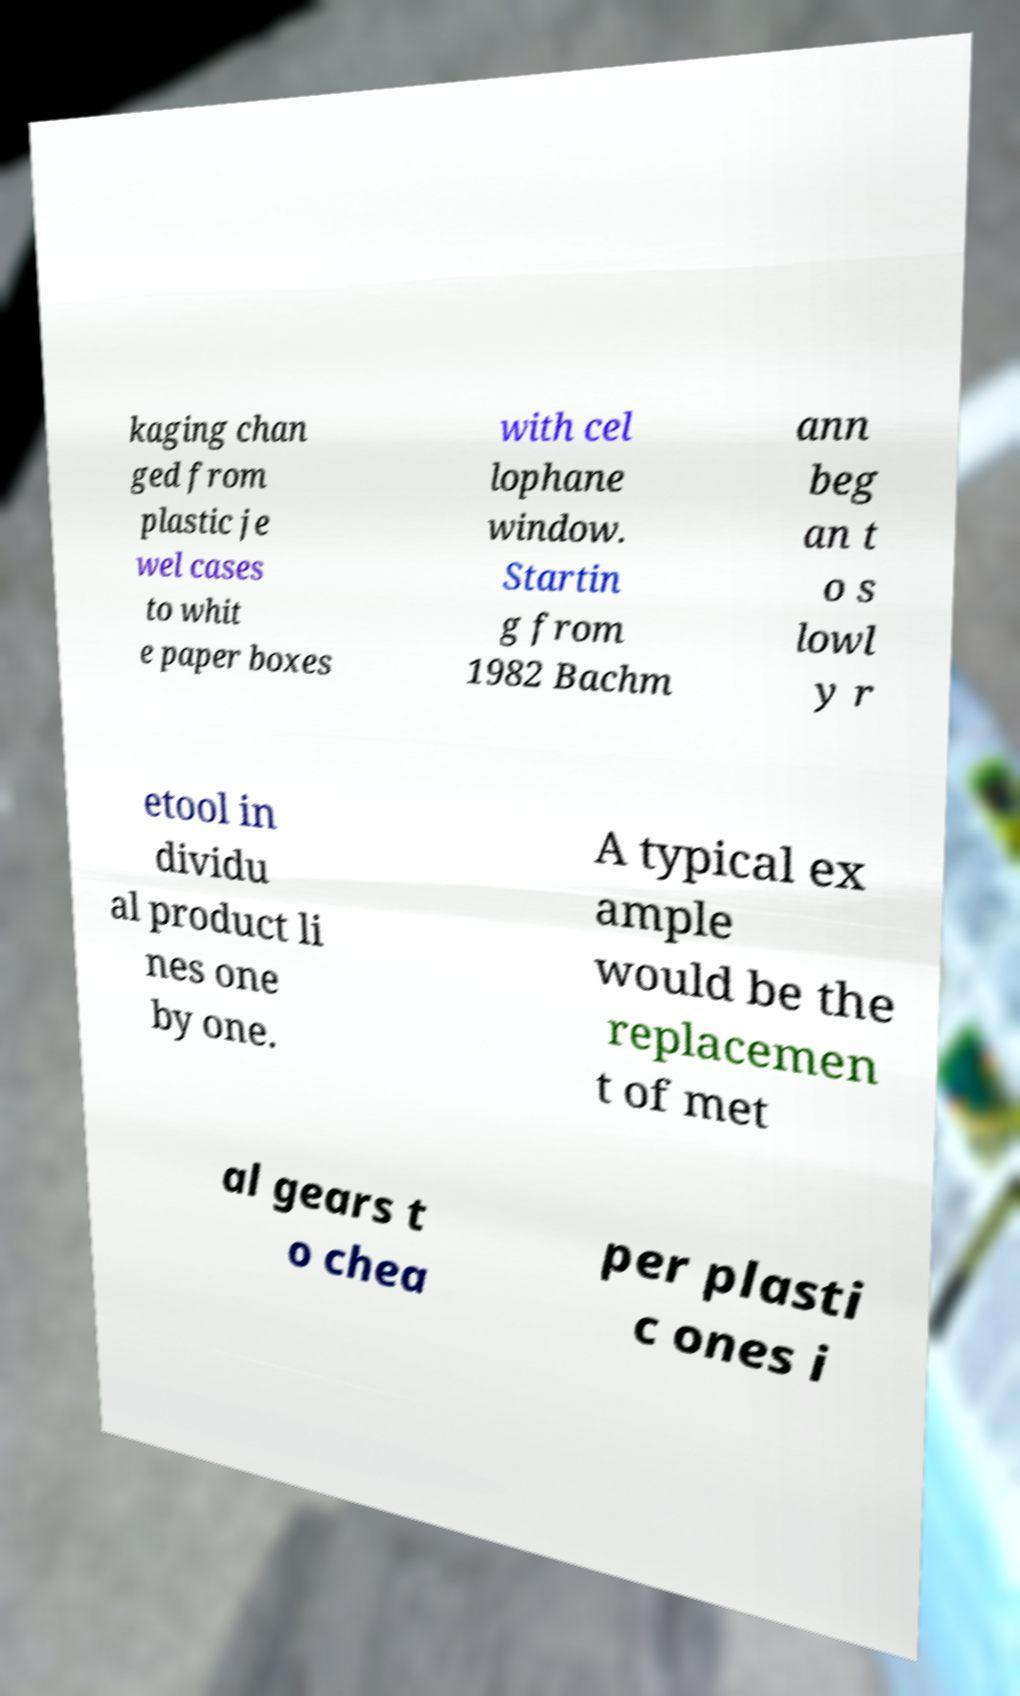What messages or text are displayed in this image? I need them in a readable, typed format. kaging chan ged from plastic je wel cases to whit e paper boxes with cel lophane window. Startin g from 1982 Bachm ann beg an t o s lowl y r etool in dividu al product li nes one by one. A typical ex ample would be the replacemen t of met al gears t o chea per plasti c ones i 